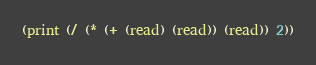Convert code to text. <code><loc_0><loc_0><loc_500><loc_500><_Lisp_>(print (/ (* (+ (read) (read)) (read)) 2))</code> 